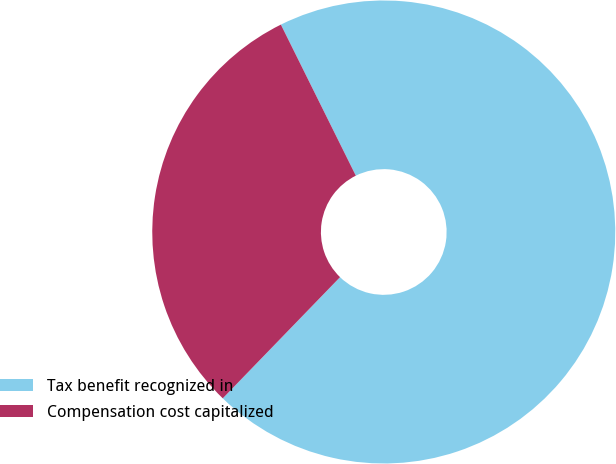<chart> <loc_0><loc_0><loc_500><loc_500><pie_chart><fcel>Tax benefit recognized in<fcel>Compensation cost capitalized<nl><fcel>69.57%<fcel>30.43%<nl></chart> 